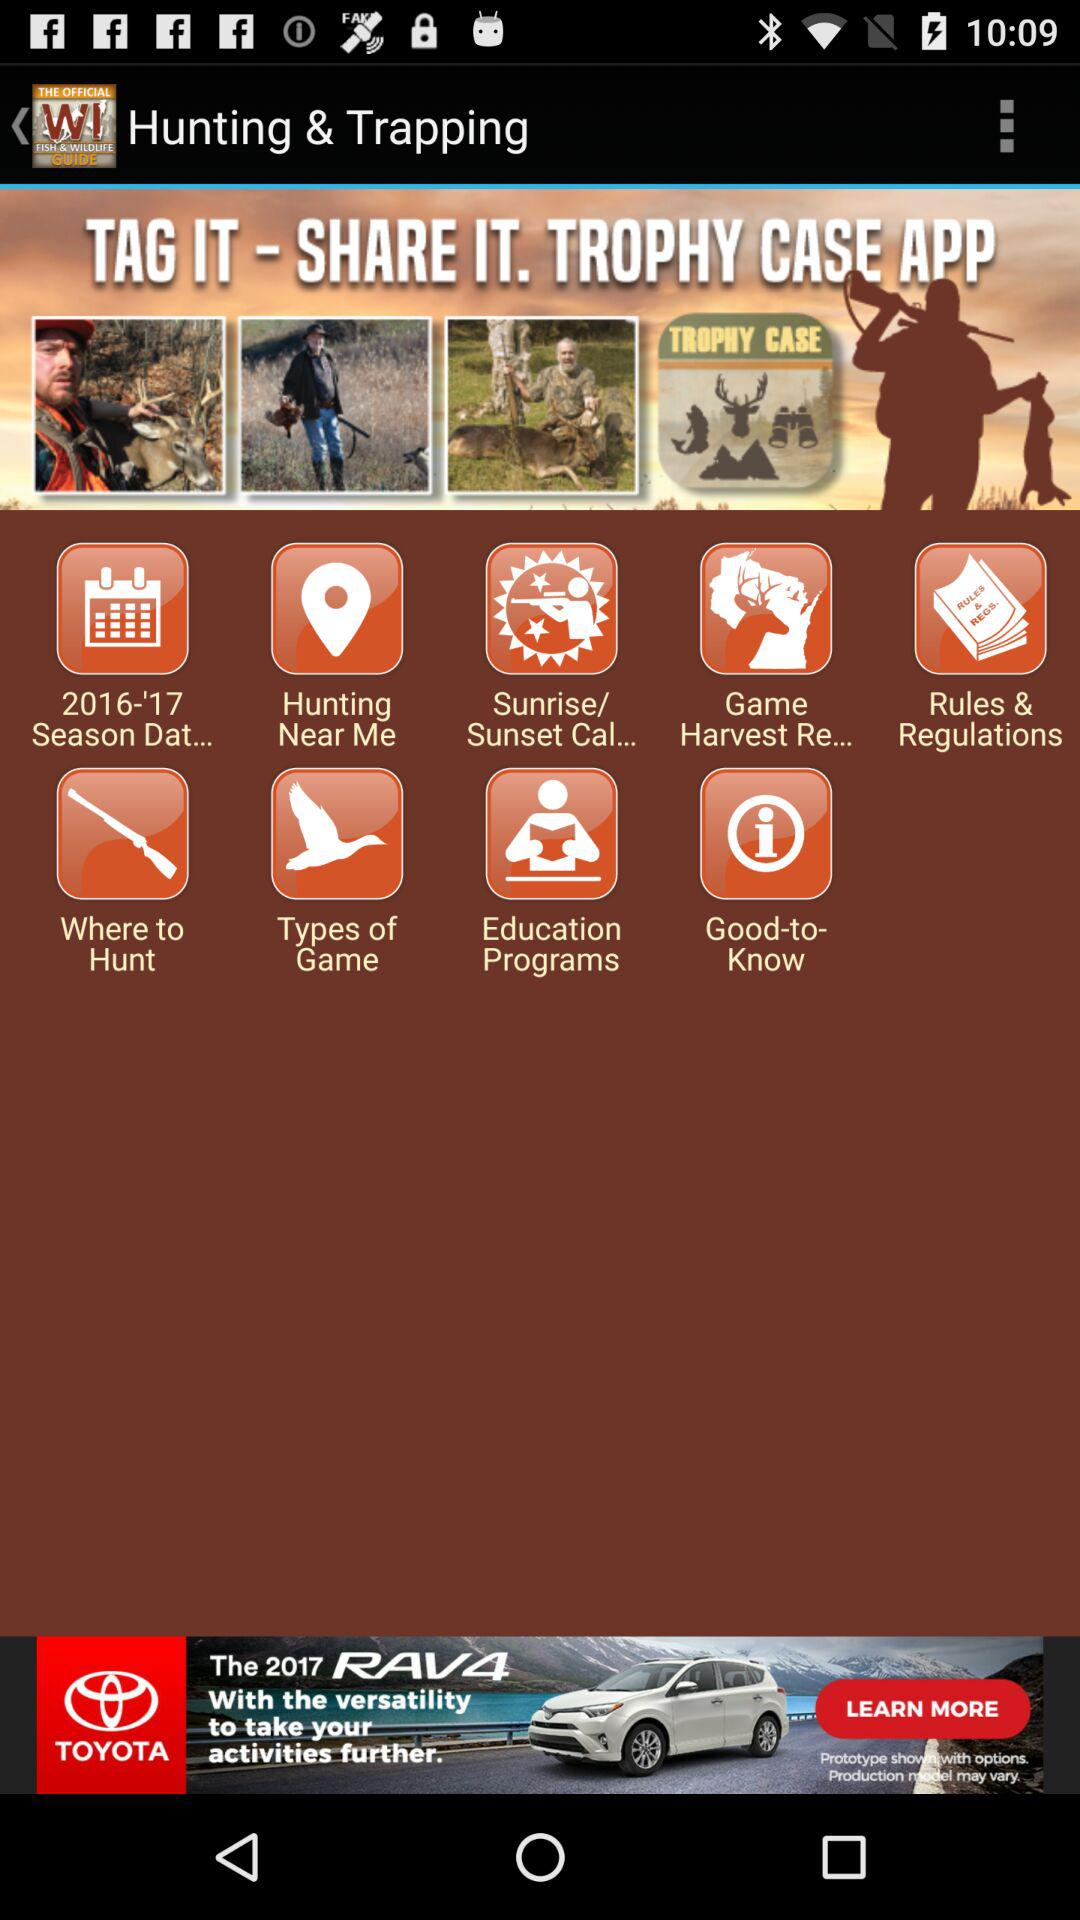What is the name of the application? The name of the application is "WI Fish & Wildlife Guide". 